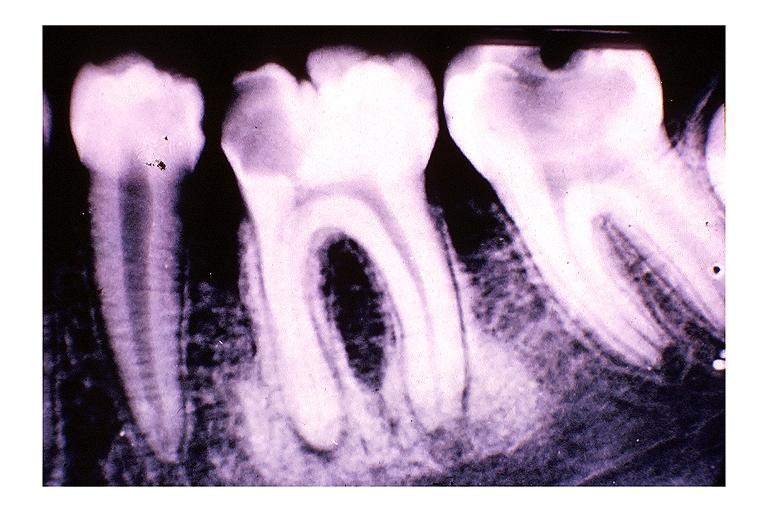does this image show focal sclerosing osteomyelitis condensing osteitis?
Answer the question using a single word or phrase. Yes 